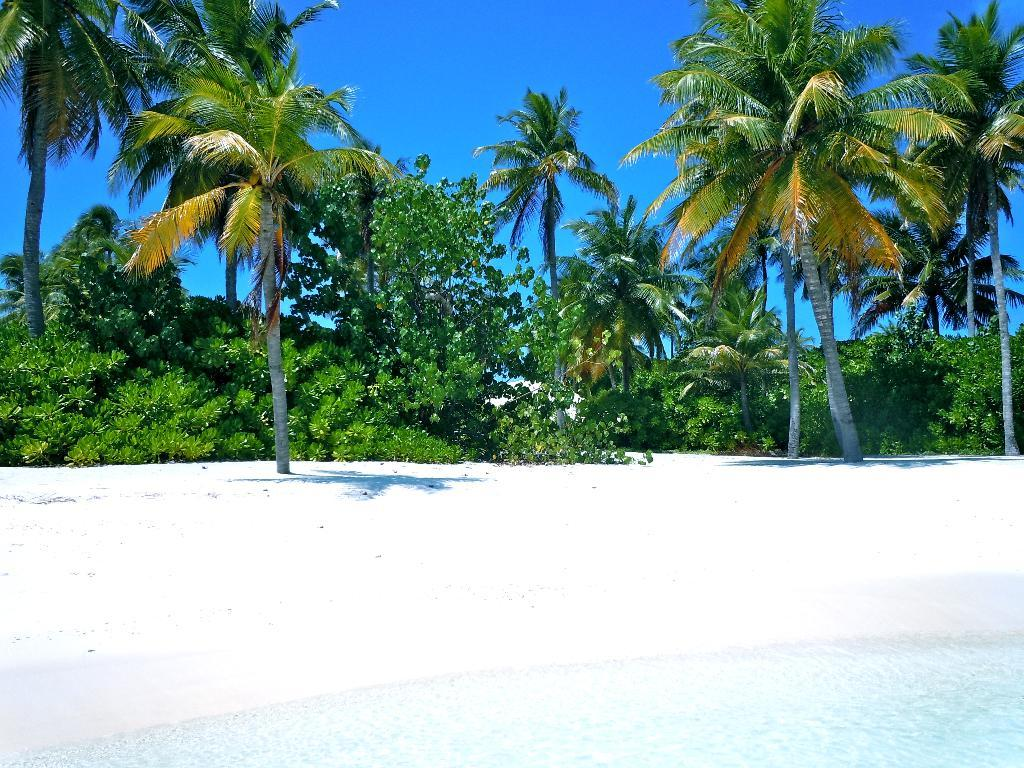What type of vegetation can be seen in the image? There are trees in the image. What natural element is visible in the image? There is water visible in the image. What type of toys can be seen floating in the water in the image? There are no toys visible in the image; it only features trees and water. What type of poison is present in the image? There is no poison present in the image; it only features trees and water. 